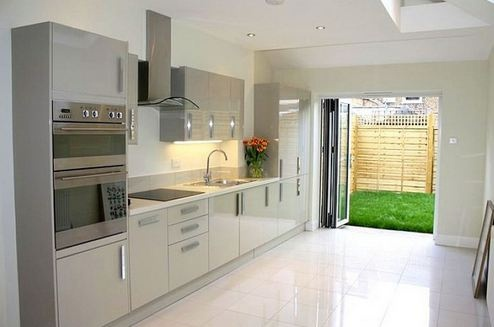Describe the objects in this image and their specific colors. I can see oven in darkgray, gray, darkgreen, and black tones, potted plant in darkgray, olive, black, gray, and maroon tones, and sink in darkgray and tan tones in this image. 